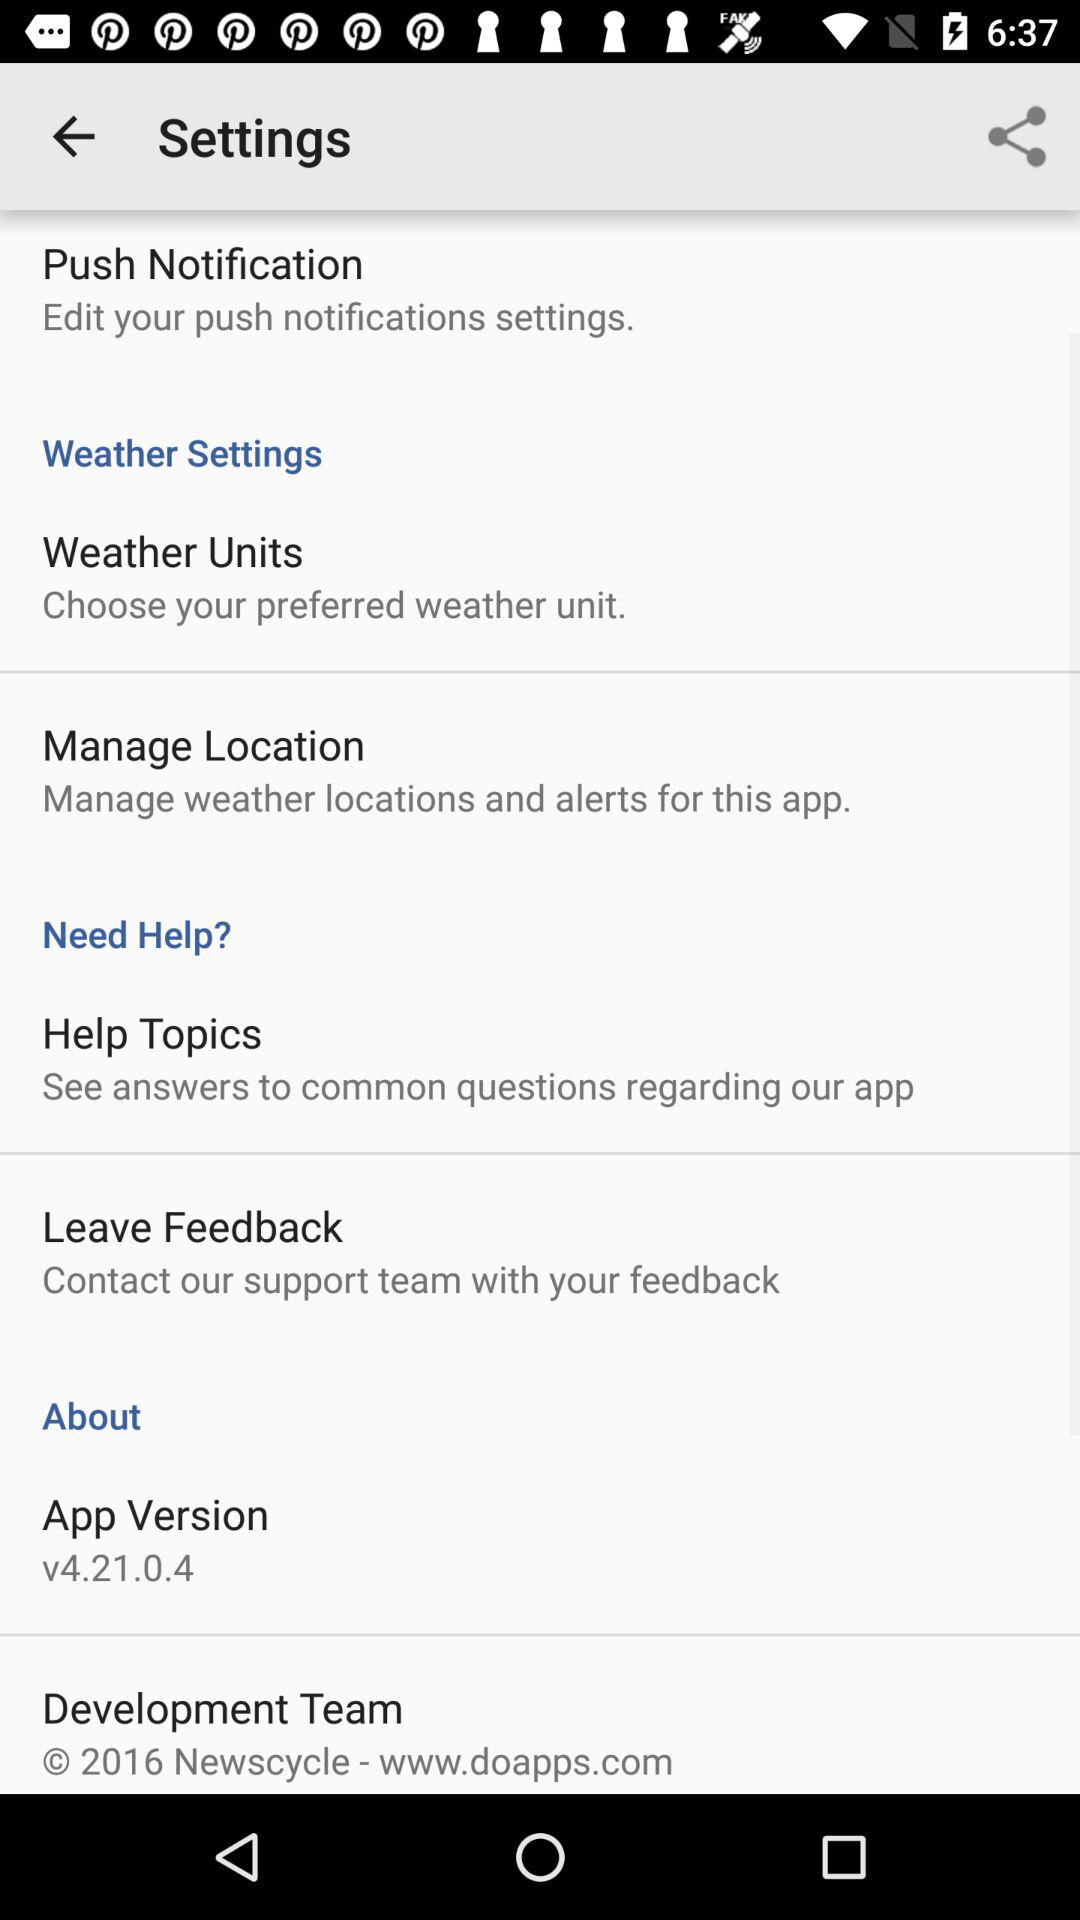What is the website address of the development team? The website address is www.doapps.com. 